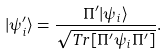Convert formula to latex. <formula><loc_0><loc_0><loc_500><loc_500>| \psi _ { i } ^ { \prime } \rangle = \frac { \Pi ^ { \prime } | \psi _ { i } \rangle } { \sqrt { T r [ \Pi ^ { \prime } \psi _ { i } \Pi ^ { \prime } ] } } .</formula> 